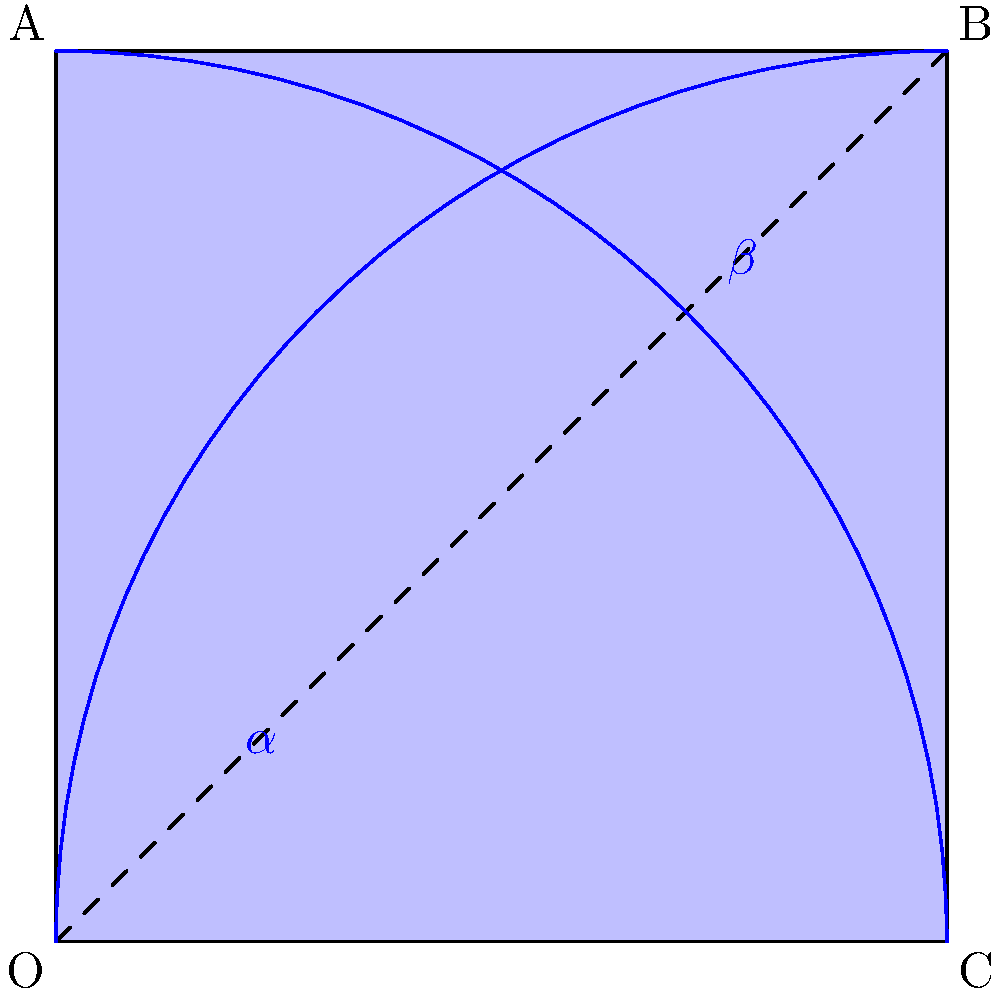In a hyperbolic plane, two parallel lines diverge from each other as they extend to infinity. Consider the figure above representing a quadrilateral OABC in a hyperbolic plane. If the sum of the interior angles $\alpha$ and $\beta$ is less than $\pi$ radians, what can be concluded about lines OB and AC? To answer this question, let's consider the properties of hyperbolic geometry and parallel lines:

1. In Euclidean geometry, the sum of interior angles of a quadrilateral is always $2\pi$ radians (360°).

2. In hyperbolic geometry, the sum of interior angles of a quadrilateral is always less than $2\pi$ radians.

3. The defect (difference between $2\pi$ and the sum of interior angles) is proportional to the area of the quadrilateral in hyperbolic space.

4. In the given figure, we're told that $\alpha + \beta < \pi$ radians.

5. This implies that the sum of all four interior angles is less than $2\pi$ radians, which is consistent with hyperbolic geometry.

6. In hyperbolic geometry, parallel lines diverge from each other as they extend to infinity.

7. The lines OB and AC are not adjacent in the quadrilateral, meaning they don't share a vertex.

8. Given that the sum of $\alpha$ and $\beta$ is less than $\pi$, it suggests a significant defect in the quadrilateral's angle sum.

9. This defect indicates a strong hyperbolic curvature, which would cause non-adjacent lines to diverge more rapidly.

Therefore, we can conclude that lines OB and AC are parallel and will diverge from each other as they extend to infinity in this hyperbolic plane.
Answer: OB and AC are parallel and divergent. 